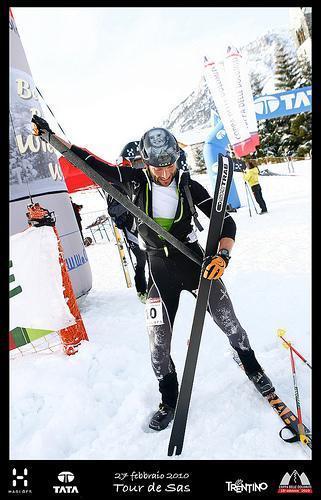How many people have on ski equipment?
Give a very brief answer. 1. 